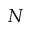Convert formula to latex. <formula><loc_0><loc_0><loc_500><loc_500>N</formula> 